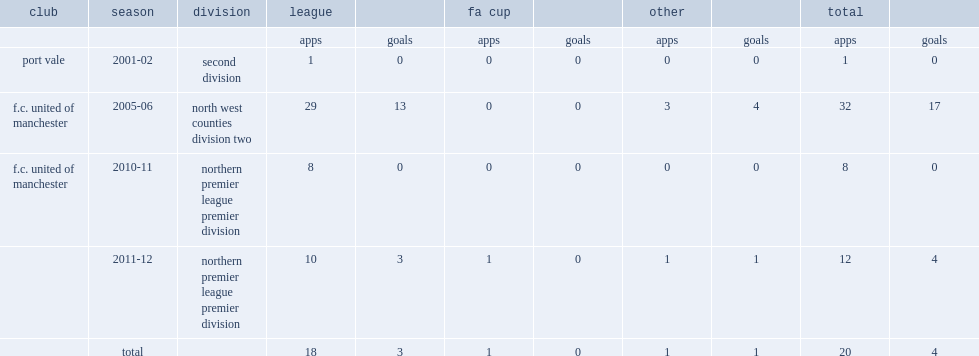In 2010, which club in the northern premier league premier division did steve torpey playe for? F.c. united of manchester. 